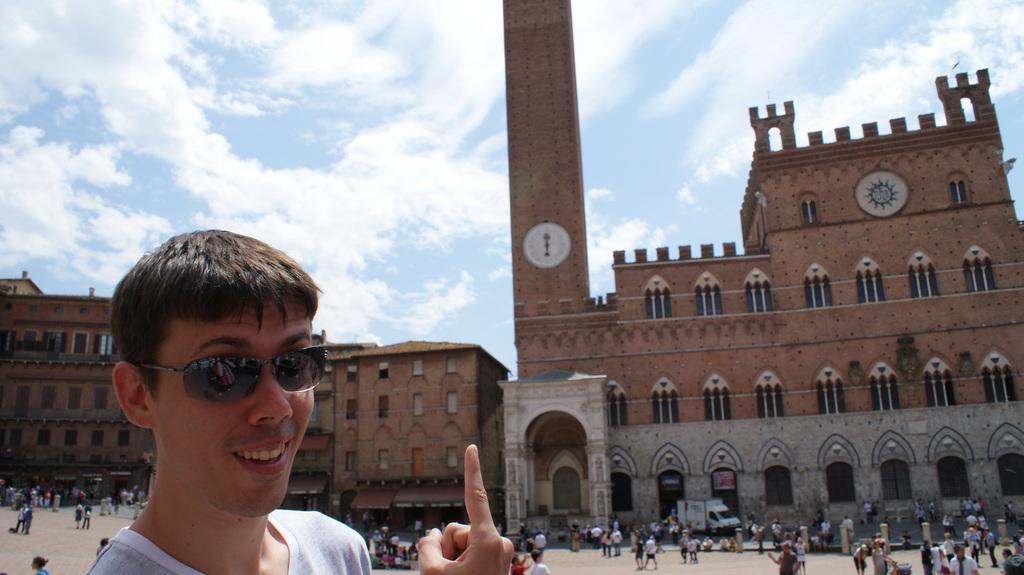In one or two sentences, can you explain what this image depicts? In the bottom left side of the image a person is standing and smiling. Behind him few people are standing and walking and there are some vehicles. In the middle of the image there are some buildings. Behind the buildings there are some clouds in the sky. 